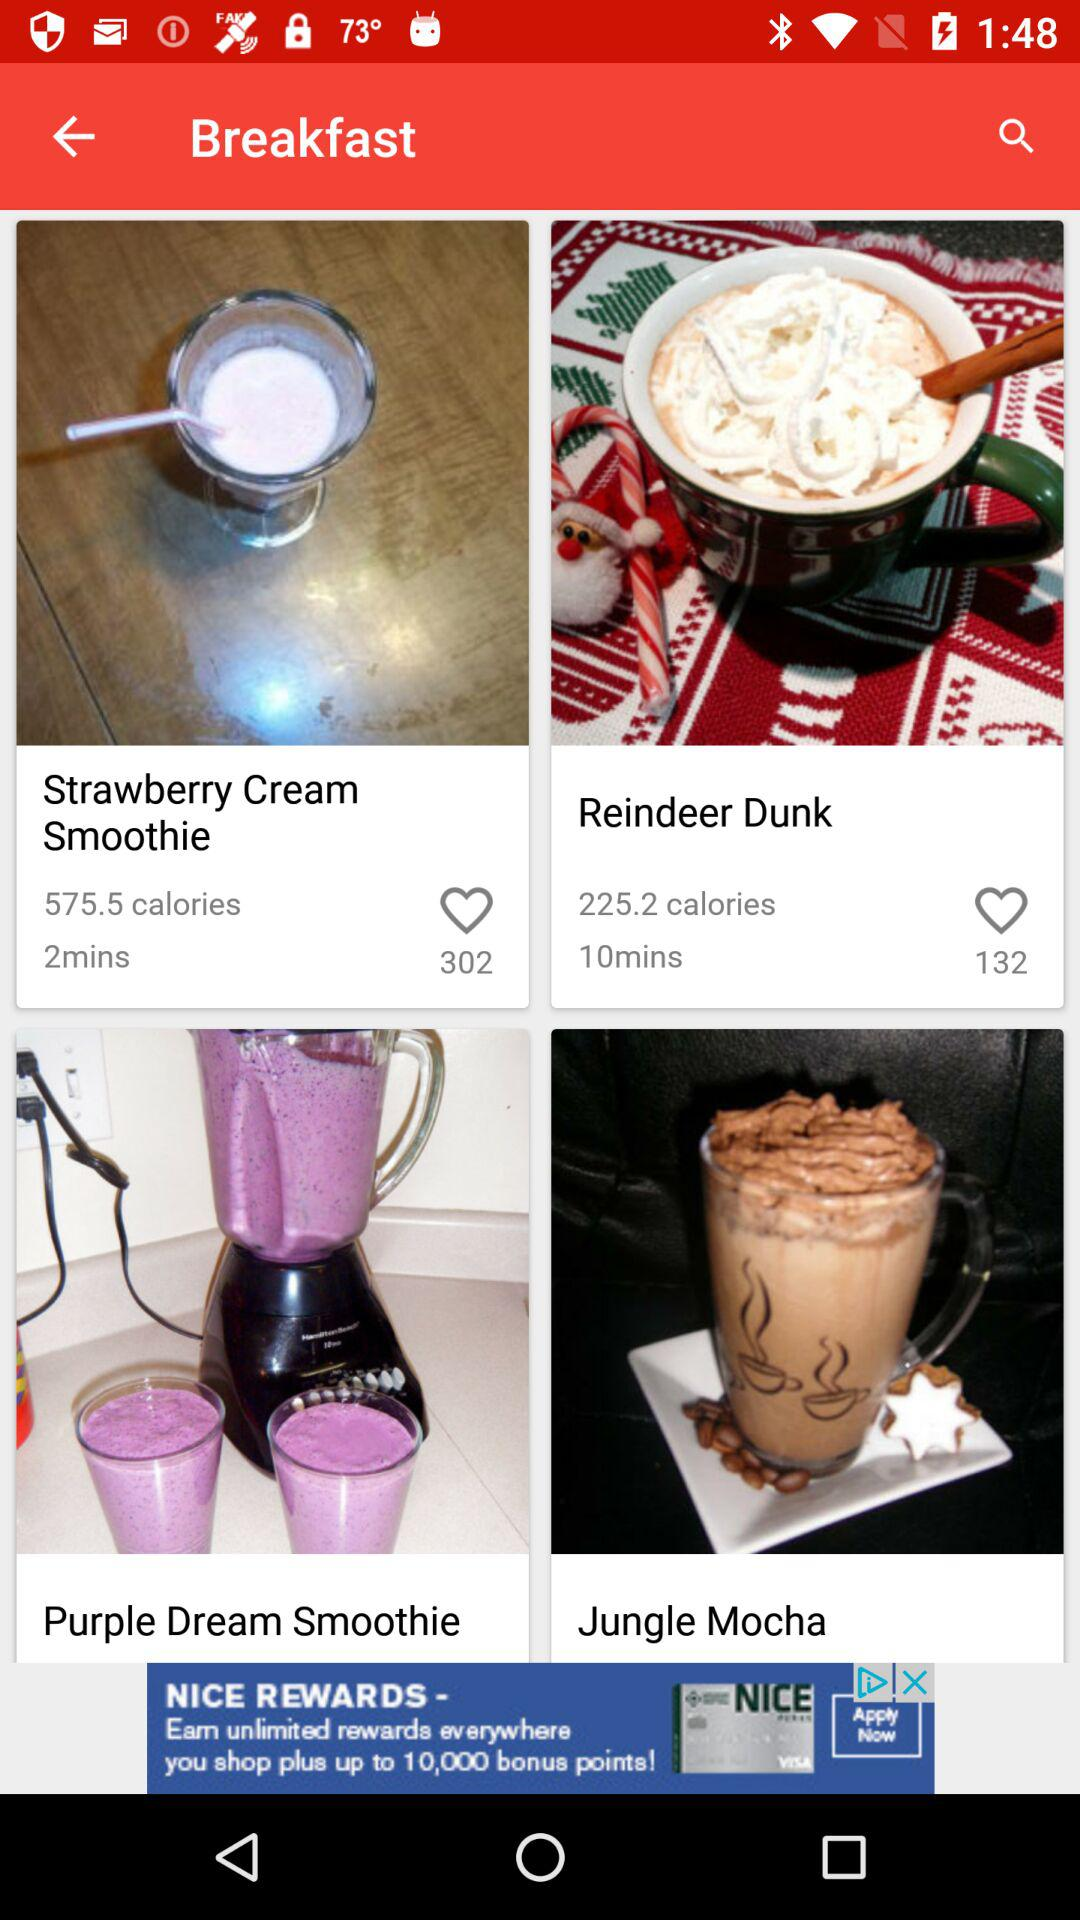How much time does it take to make the Strawberry Cream Smoothie? It takes 2 minutes to make the Strawberry Cream Smoothie. 